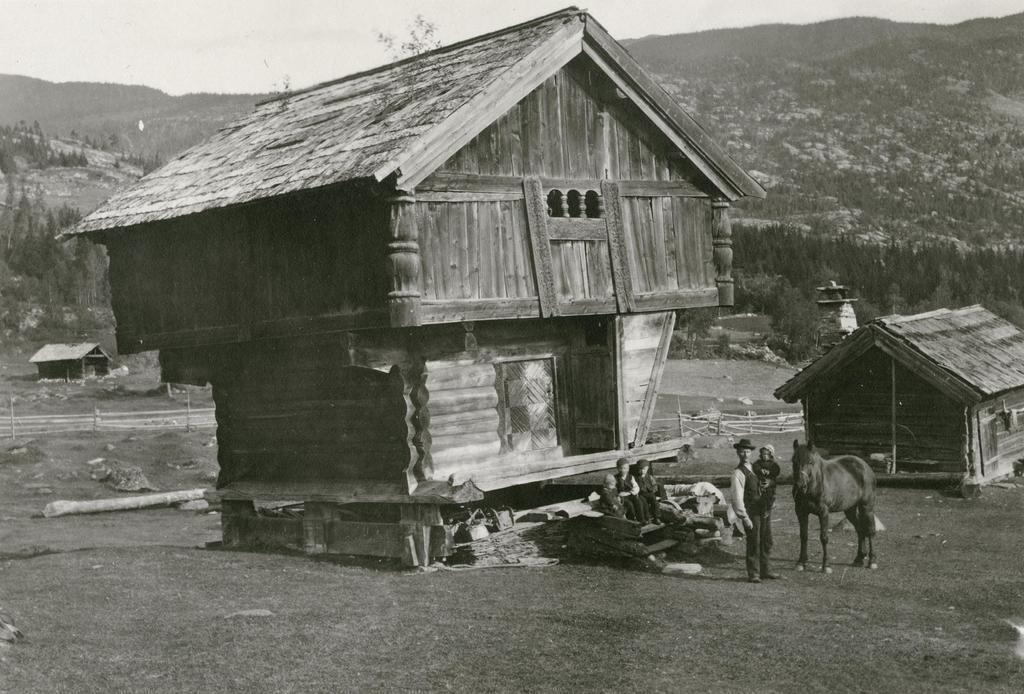How would you summarize this image in a sentence or two? This is a black and white picture. In the background we can see sky, hills and trees. In this picture we can see houses and people sitting behind to a man. We can see a man wearing a hat and carrying a baby. Beside to him we can see an animal. 